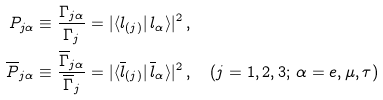<formula> <loc_0><loc_0><loc_500><loc_500>P _ { j \alpha } & \equiv \frac { \Gamma _ { j \alpha } } { \Gamma _ { j } } = | \langle l _ { ( j ) } | \, l _ { \alpha } \rangle | ^ { 2 } \, , \\ \quad \overline { P } _ { j \alpha } & \equiv \frac { \overline { \Gamma } _ { j \alpha } } { \overline { \Gamma } _ { j } } = | \langle \overline { l } _ { ( j ) } | \, \overline { l } _ { \alpha } \rangle | ^ { 2 } \, , \quad ( j = 1 , 2 , 3 ; \, \alpha = e , \mu , \tau )</formula> 